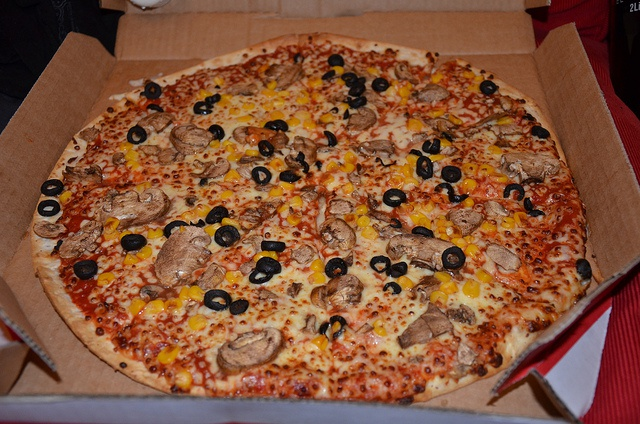Describe the objects in this image and their specific colors. I can see a pizza in black, brown, gray, maroon, and tan tones in this image. 